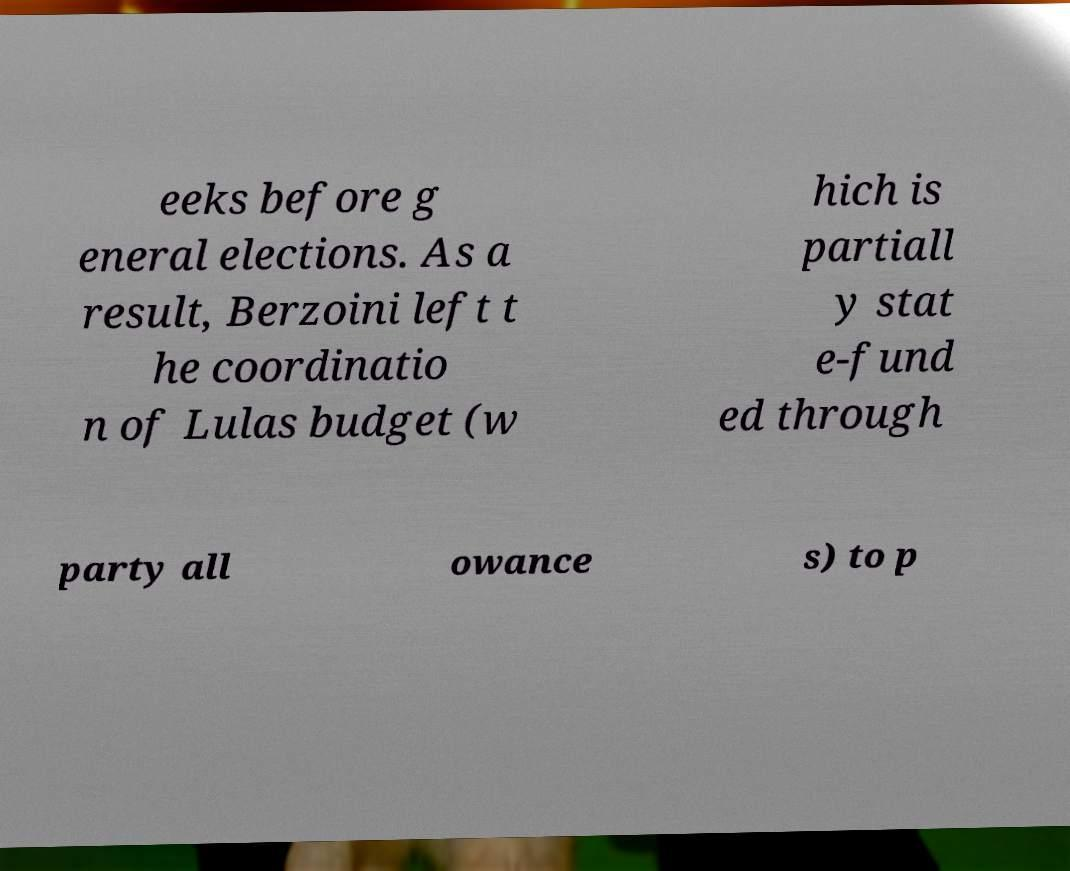Please read and relay the text visible in this image. What does it say? eeks before g eneral elections. As a result, Berzoini left t he coordinatio n of Lulas budget (w hich is partiall y stat e-fund ed through party all owance s) to p 